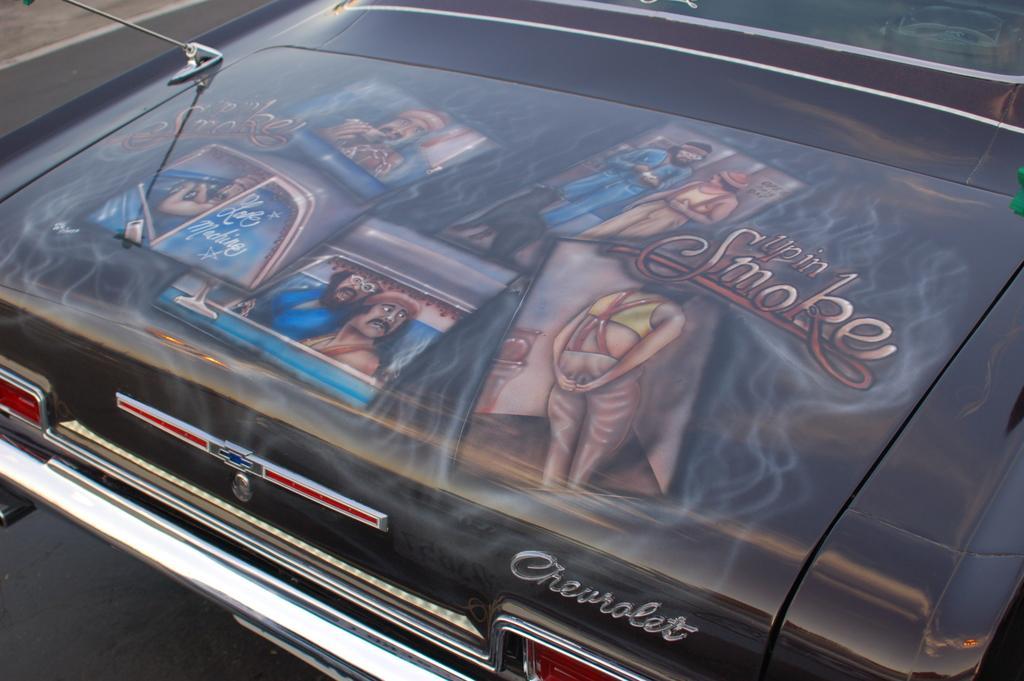How would you summarize this image in a sentence or two? In the foreground of this image, there are paintings on the bonnet of the car which is on the road. 